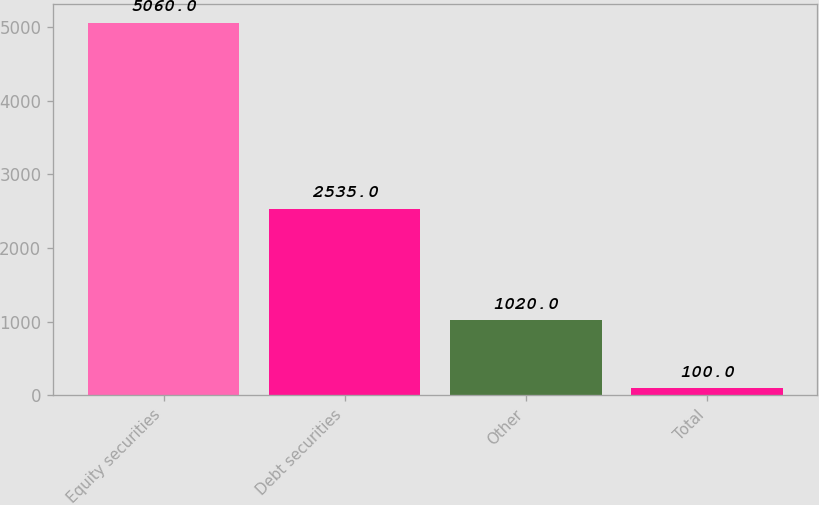Convert chart. <chart><loc_0><loc_0><loc_500><loc_500><bar_chart><fcel>Equity securities<fcel>Debt securities<fcel>Other<fcel>Total<nl><fcel>5060<fcel>2535<fcel>1020<fcel>100<nl></chart> 